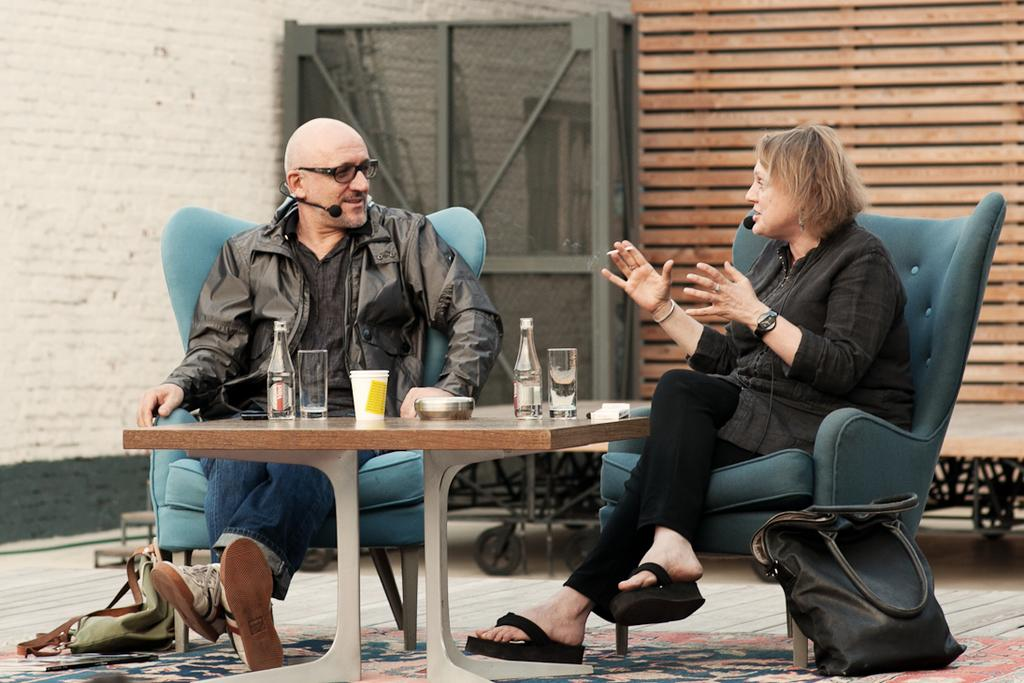How many people are sitting in the image? There are two persons sitting on chairs in the image. What is present on the table in the image? There are bottles and glasses on the table in the image. What can be seen on the floor in the image? There are bags on the floor in the image. What is visible in the background of the image? There is a wall in the background of the image. What type of jar is being used to stop the meeting in the image? There is no jar or meeting present in the image. 